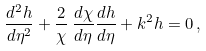Convert formula to latex. <formula><loc_0><loc_0><loc_500><loc_500>\frac { d ^ { 2 } h } { d \eta ^ { 2 } } + \frac { 2 } { \chi } \, \frac { d \chi } { d \eta } \frac { d h } { d \eta } + k ^ { 2 } h = 0 \, ,</formula> 